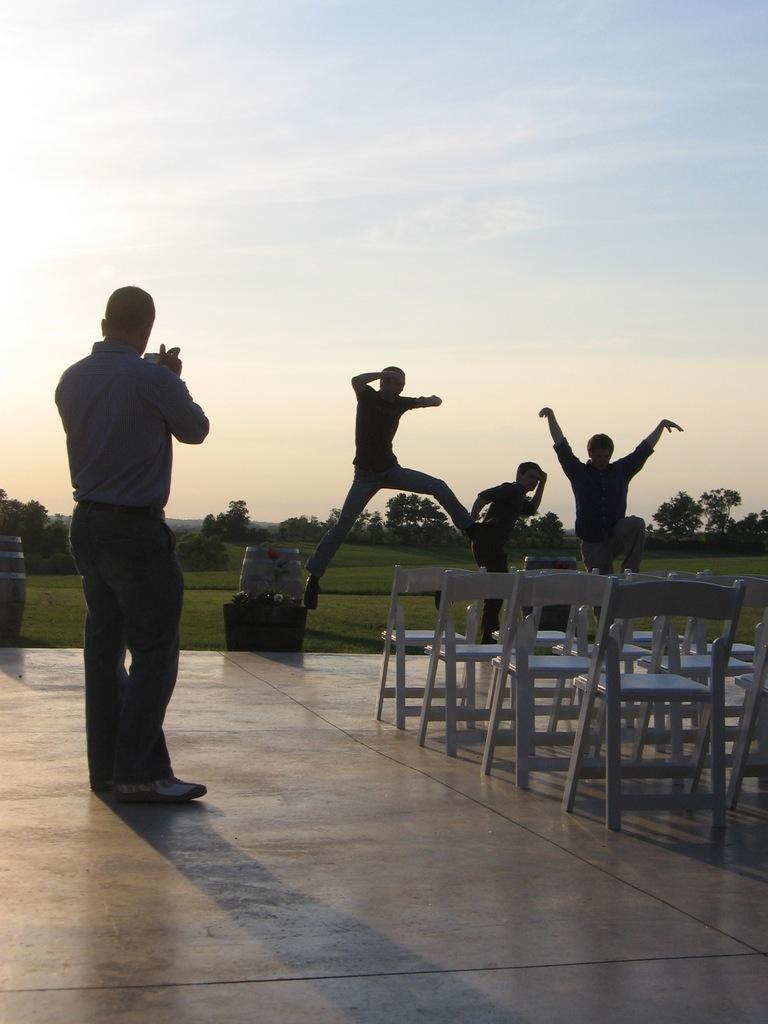Could you give a brief overview of what you see in this image? In this image i can see a person standing and holding an object in his hand, I can see few chairs to the right of the image. In the background i can see few persons jumping, few trees, grass and the sky. 